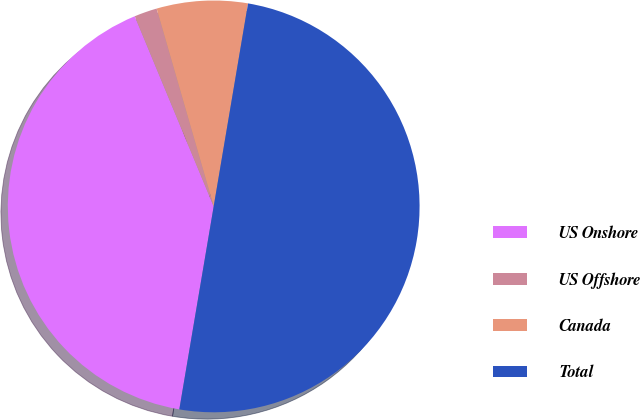Convert chart. <chart><loc_0><loc_0><loc_500><loc_500><pie_chart><fcel>US Onshore<fcel>US Offshore<fcel>Canada<fcel>Total<nl><fcel>41.07%<fcel>1.79%<fcel>7.14%<fcel>50.0%<nl></chart> 